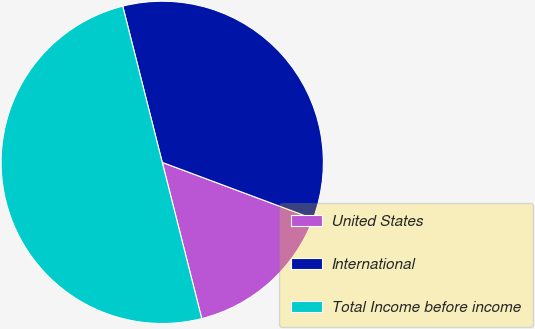<chart> <loc_0><loc_0><loc_500><loc_500><pie_chart><fcel>United States<fcel>International<fcel>Total Income before income<nl><fcel>15.37%<fcel>34.63%<fcel>50.0%<nl></chart> 